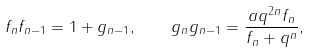<formula> <loc_0><loc_0><loc_500><loc_500>f _ { n } f _ { n - 1 } = 1 + g _ { n - 1 } , \quad g _ { n } g _ { n - 1 } = \frac { a q ^ { 2 n } f _ { n } } { f _ { n } + q ^ { n } } ,</formula> 